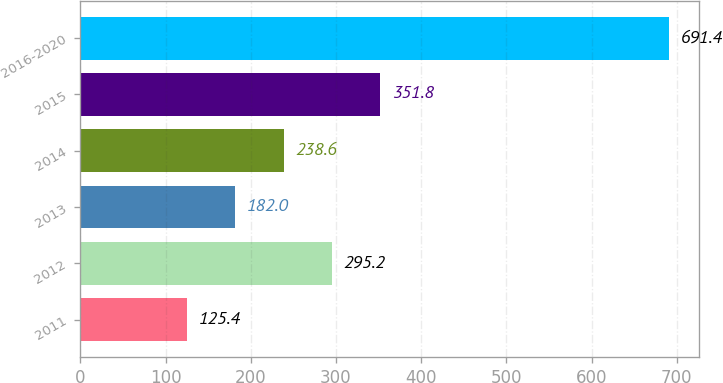Convert chart to OTSL. <chart><loc_0><loc_0><loc_500><loc_500><bar_chart><fcel>2011<fcel>2012<fcel>2013<fcel>2014<fcel>2015<fcel>2016-2020<nl><fcel>125.4<fcel>295.2<fcel>182<fcel>238.6<fcel>351.8<fcel>691.4<nl></chart> 